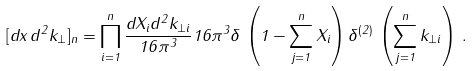<formula> <loc_0><loc_0><loc_500><loc_500>[ d x \, d ^ { 2 } { k } _ { \perp } ] _ { n } = \prod _ { i = 1 } ^ { n } \frac { d X _ { i } d ^ { 2 } { k } _ { \perp i } } { 1 6 \pi ^ { 3 } } 1 6 \pi ^ { 3 } \delta \, \left ( 1 - \sum _ { j = 1 } ^ { n } X _ { i } \right ) \delta ^ { ( 2 ) } \, \left ( \sum _ { j = 1 } ^ { n } { k } _ { \perp i } \right ) \, .</formula> 